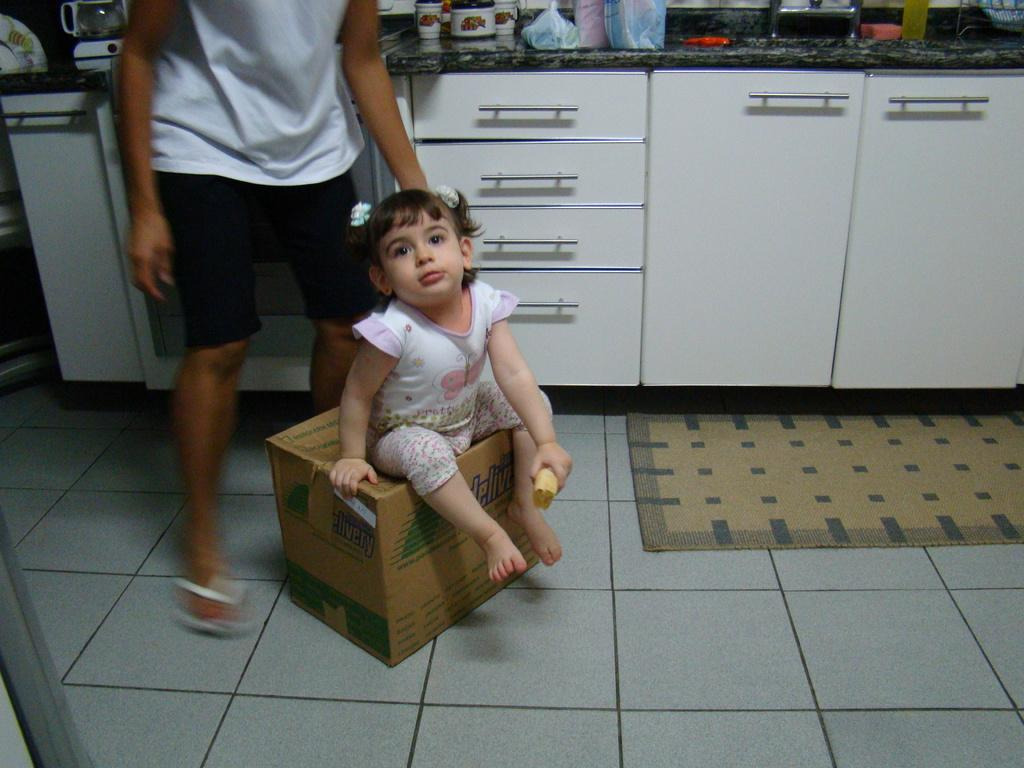<image>
Give a short and clear explanation of the subsequent image. a little girl sitting on a brown delivery box 